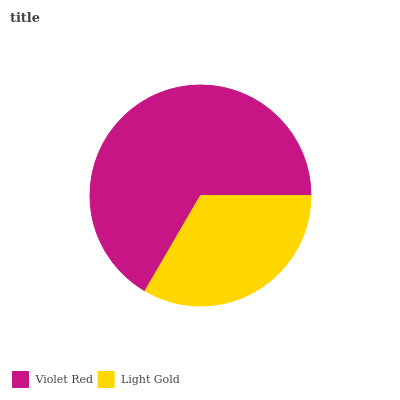Is Light Gold the minimum?
Answer yes or no. Yes. Is Violet Red the maximum?
Answer yes or no. Yes. Is Light Gold the maximum?
Answer yes or no. No. Is Violet Red greater than Light Gold?
Answer yes or no. Yes. Is Light Gold less than Violet Red?
Answer yes or no. Yes. Is Light Gold greater than Violet Red?
Answer yes or no. No. Is Violet Red less than Light Gold?
Answer yes or no. No. Is Violet Red the high median?
Answer yes or no. Yes. Is Light Gold the low median?
Answer yes or no. Yes. Is Light Gold the high median?
Answer yes or no. No. Is Violet Red the low median?
Answer yes or no. No. 